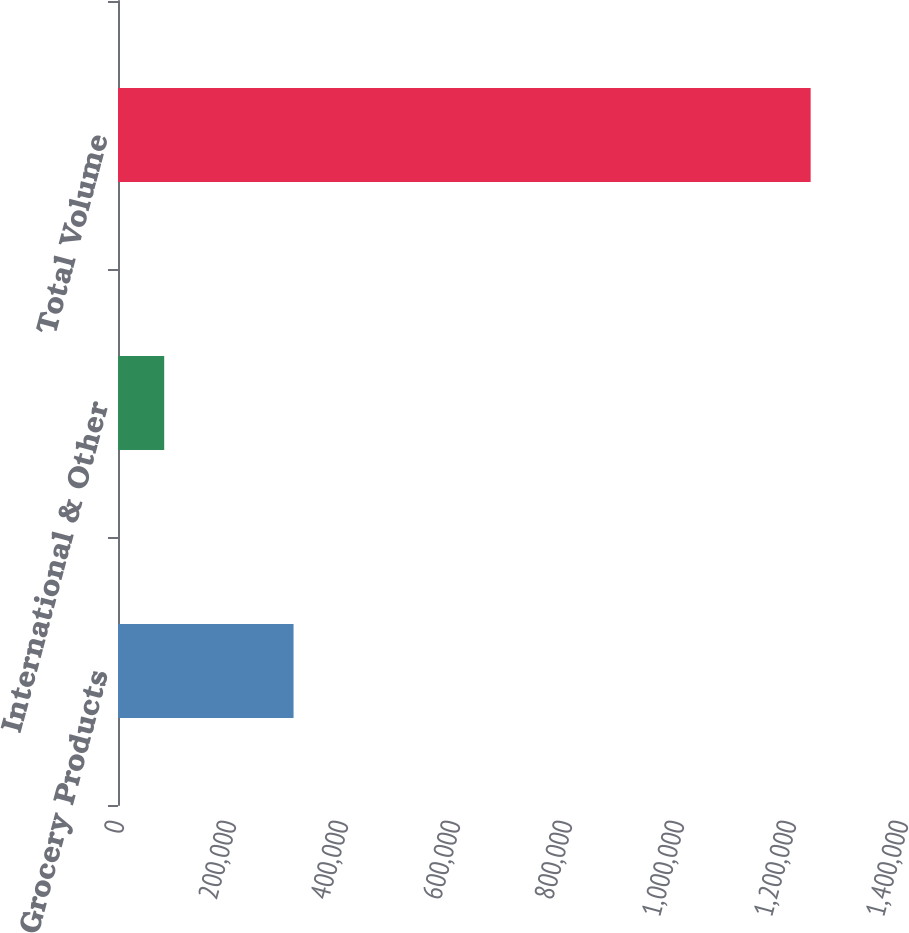Convert chart to OTSL. <chart><loc_0><loc_0><loc_500><loc_500><bar_chart><fcel>Grocery Products<fcel>International & Other<fcel>Total Volume<nl><fcel>313489<fcel>82493<fcel>1.23688e+06<nl></chart> 